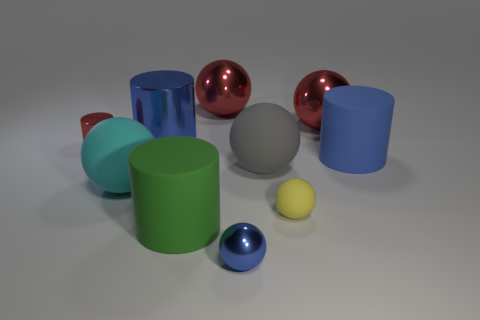Which object stands out the most, and why? The large red glossy sphere stands out the most due to its vibrant color and reflective surface that draws the eye amidst the other more subdued colors and matte finishes. 